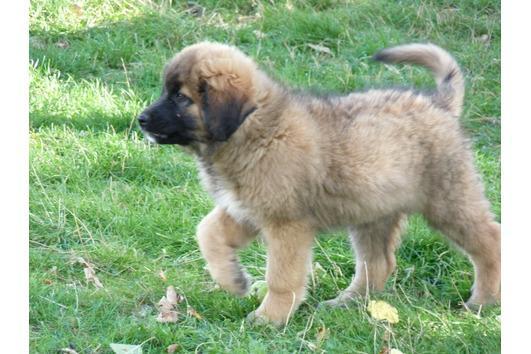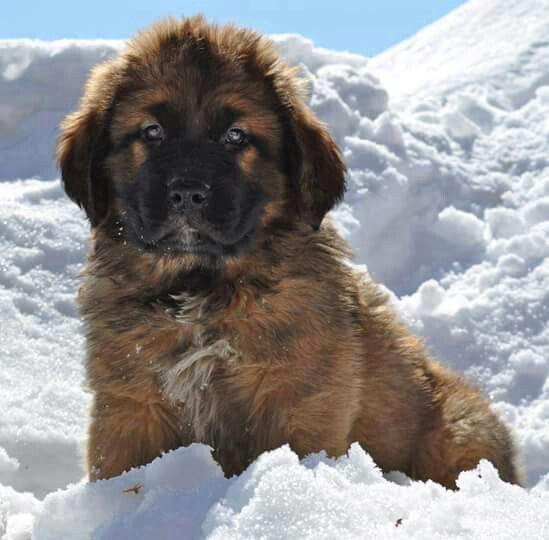The first image is the image on the left, the second image is the image on the right. Evaluate the accuracy of this statement regarding the images: "A image shows one dog in a snowy outdoor setting.". Is it true? Answer yes or no. Yes. The first image is the image on the left, the second image is the image on the right. Examine the images to the left and right. Is the description "The dog in one of the images in on grass" accurate? Answer yes or no. Yes. 